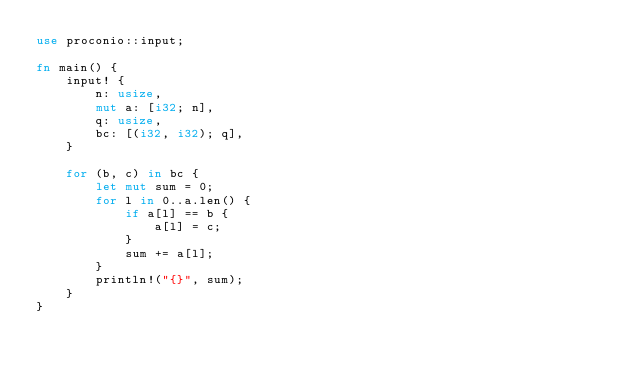Convert code to text. <code><loc_0><loc_0><loc_500><loc_500><_Rust_>use proconio::input;

fn main() {
    input! {
        n: usize,
        mut a: [i32; n],
        q: usize,
        bc: [(i32, i32); q],
    }

    for (b, c) in bc {
        let mut sum = 0;
        for l in 0..a.len() {
            if a[l] == b {
                a[l] = c;
            }
            sum += a[l];
        }
        println!("{}", sum);
    }
}</code> 